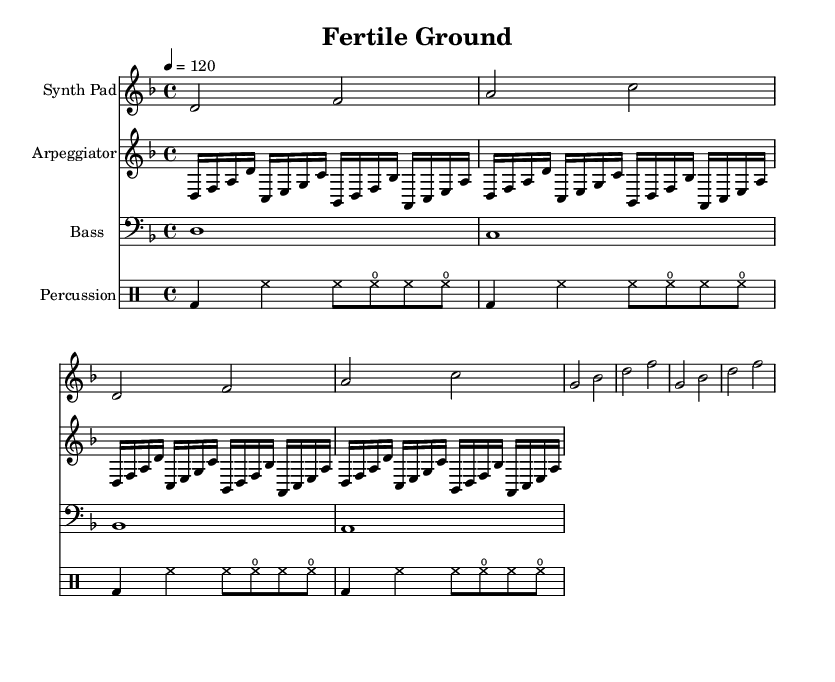What is the key signature of this music? The key signature is D minor, which has one flat (B flat) indicated. This can be seen at the beginning of the staff.
Answer: D minor What is the time signature of this music? The time signature is 4/4, which indicates four beats per measure, as can be seen at the beginning of the score.
Answer: 4/4 What is the tempo marking? The tempo marking indicates a speed of 120 beats per minute, denoted in the score with "4 = 120". This shows the number of beats in a minute.
Answer: 120 What instrument plays the Synth Pad part? The Synth Pad part is indicated by the staff labeled "Synth Pad". It shows that a synth instrument is used for this section of the music.
Answer: Synth Pad Which musical section contains the percussion? The percussion is written in the staff labeled "Percussion", where the drum patterns are notated. This clearly designates what part of the composition includes the percussion instruments.
Answer: Percussion How many measures are in the arpeggiator section? The arpeggiator section has four measures shown. Counting the repeated unfolding and concluding the notes gives the total measure count in this part.
Answer: 4 What is the progression of the Bass notes? The Bass notes progress through D, C, B flat, and A. This can be determined by viewing the notes themselves in the Bass staff section.
Answer: D, C, B flat, A 